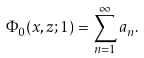Convert formula to latex. <formula><loc_0><loc_0><loc_500><loc_500>\Phi _ { 0 } ( x , z ; 1 ) = \sum _ { n = 1 } ^ { \infty } a _ { n } .</formula> 